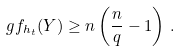<formula> <loc_0><loc_0><loc_500><loc_500>\ g f _ { h _ { t } } ( Y ) \geq n \left ( \frac { n } { q } - 1 \right ) \, .</formula> 